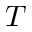<formula> <loc_0><loc_0><loc_500><loc_500>{ T }</formula> 